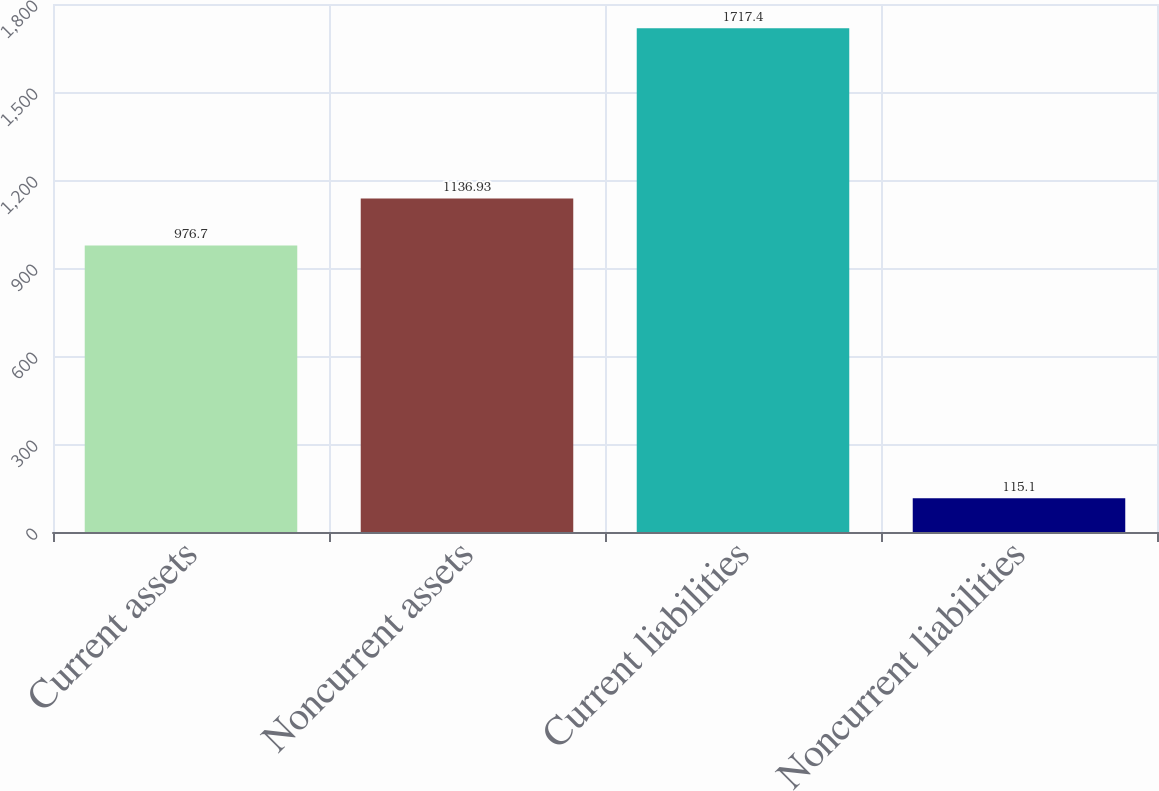Convert chart to OTSL. <chart><loc_0><loc_0><loc_500><loc_500><bar_chart><fcel>Current assets<fcel>Noncurrent assets<fcel>Current liabilities<fcel>Noncurrent liabilities<nl><fcel>976.7<fcel>1136.93<fcel>1717.4<fcel>115.1<nl></chart> 